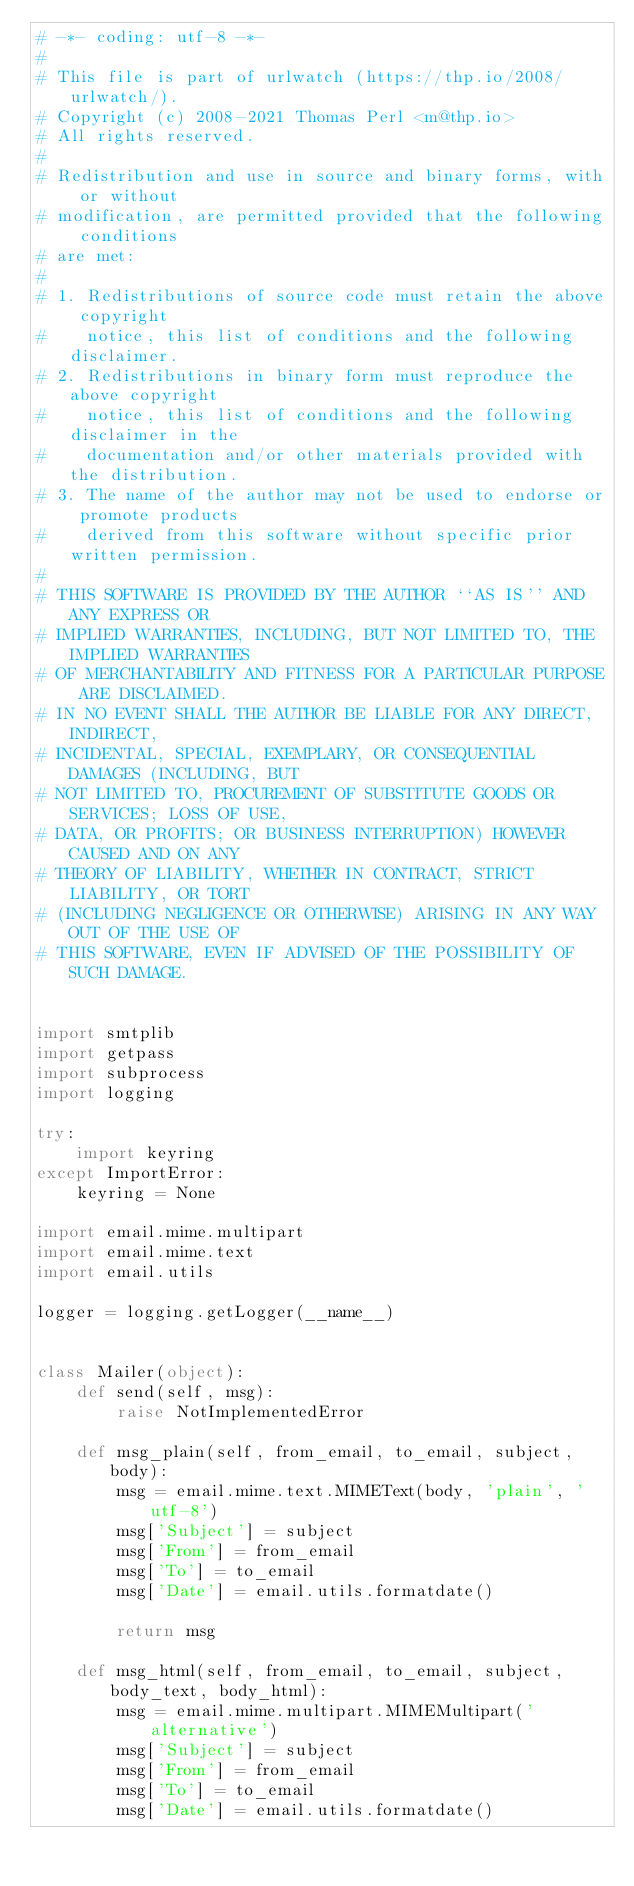Convert code to text. <code><loc_0><loc_0><loc_500><loc_500><_Python_># -*- coding: utf-8 -*-
#
# This file is part of urlwatch (https://thp.io/2008/urlwatch/).
# Copyright (c) 2008-2021 Thomas Perl <m@thp.io>
# All rights reserved.
#
# Redistribution and use in source and binary forms, with or without
# modification, are permitted provided that the following conditions
# are met:
#
# 1. Redistributions of source code must retain the above copyright
#    notice, this list of conditions and the following disclaimer.
# 2. Redistributions in binary form must reproduce the above copyright
#    notice, this list of conditions and the following disclaimer in the
#    documentation and/or other materials provided with the distribution.
# 3. The name of the author may not be used to endorse or promote products
#    derived from this software without specific prior written permission.
#
# THIS SOFTWARE IS PROVIDED BY THE AUTHOR ``AS IS'' AND ANY EXPRESS OR
# IMPLIED WARRANTIES, INCLUDING, BUT NOT LIMITED TO, THE IMPLIED WARRANTIES
# OF MERCHANTABILITY AND FITNESS FOR A PARTICULAR PURPOSE ARE DISCLAIMED.
# IN NO EVENT SHALL THE AUTHOR BE LIABLE FOR ANY DIRECT, INDIRECT,
# INCIDENTAL, SPECIAL, EXEMPLARY, OR CONSEQUENTIAL DAMAGES (INCLUDING, BUT
# NOT LIMITED TO, PROCUREMENT OF SUBSTITUTE GOODS OR SERVICES; LOSS OF USE,
# DATA, OR PROFITS; OR BUSINESS INTERRUPTION) HOWEVER CAUSED AND ON ANY
# THEORY OF LIABILITY, WHETHER IN CONTRACT, STRICT LIABILITY, OR TORT
# (INCLUDING NEGLIGENCE OR OTHERWISE) ARISING IN ANY WAY OUT OF THE USE OF
# THIS SOFTWARE, EVEN IF ADVISED OF THE POSSIBILITY OF SUCH DAMAGE.


import smtplib
import getpass
import subprocess
import logging

try:
    import keyring
except ImportError:
    keyring = None

import email.mime.multipart
import email.mime.text
import email.utils

logger = logging.getLogger(__name__)


class Mailer(object):
    def send(self, msg):
        raise NotImplementedError

    def msg_plain(self, from_email, to_email, subject, body):
        msg = email.mime.text.MIMEText(body, 'plain', 'utf-8')
        msg['Subject'] = subject
        msg['From'] = from_email
        msg['To'] = to_email
        msg['Date'] = email.utils.formatdate()

        return msg

    def msg_html(self, from_email, to_email, subject, body_text, body_html):
        msg = email.mime.multipart.MIMEMultipart('alternative')
        msg['Subject'] = subject
        msg['From'] = from_email
        msg['To'] = to_email
        msg['Date'] = email.utils.formatdate()
</code> 